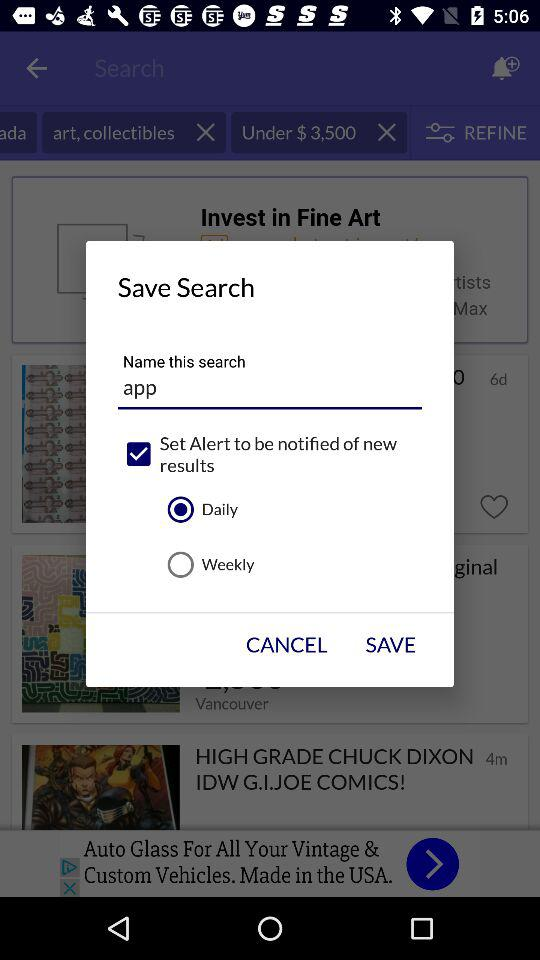How many clothing options? There are 573,999 clothing options. 